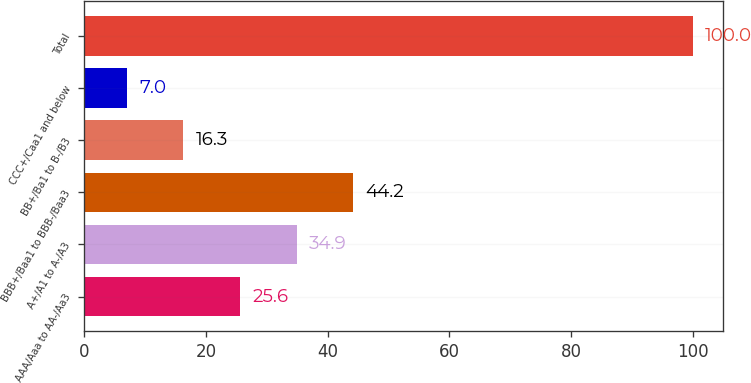Convert chart. <chart><loc_0><loc_0><loc_500><loc_500><bar_chart><fcel>AAA/Aaa to AA-/Aa3<fcel>A+/A1 to A-/A3<fcel>BBB+/Baa1 to BBB-/Baa3<fcel>BB+/Ba1 to B-/B3<fcel>CCC+/Caa1 and below<fcel>Total<nl><fcel>25.6<fcel>34.9<fcel>44.2<fcel>16.3<fcel>7<fcel>100<nl></chart> 